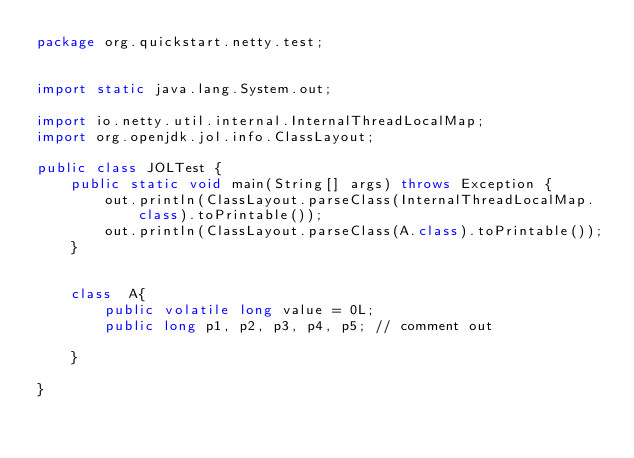Convert code to text. <code><loc_0><loc_0><loc_500><loc_500><_Java_>package org.quickstart.netty.test;


import static java.lang.System.out;

import io.netty.util.internal.InternalThreadLocalMap;
import org.openjdk.jol.info.ClassLayout;

public class JOLTest {
    public static void main(String[] args) throws Exception {
        out.println(ClassLayout.parseClass(InternalThreadLocalMap.class).toPrintable());
        out.println(ClassLayout.parseClass(A.class).toPrintable());
    }


    class  A{
        public volatile long value = 0L;
        public long p1, p2, p3, p4, p5; // comment out

    }

}</code> 